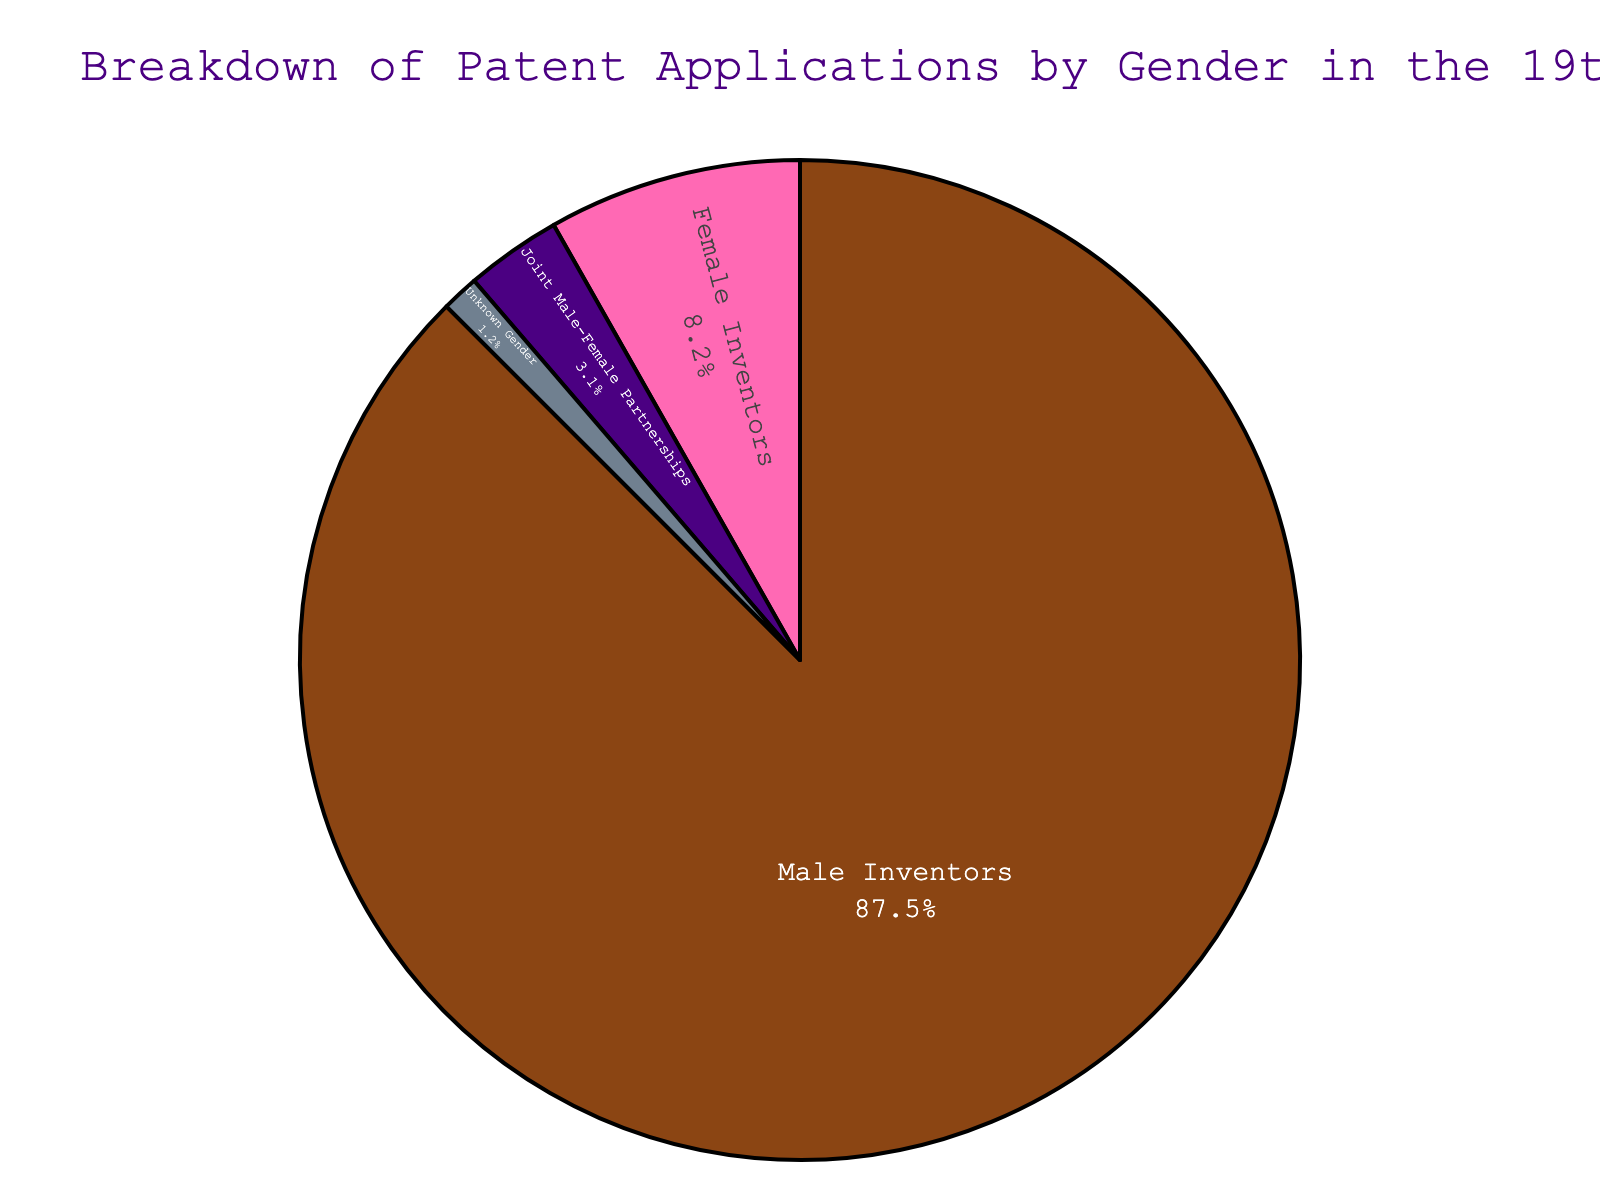What percentage of patent applications were made by joint male-female partnerships? To find the percentage of patent applications made by joint male-female partnerships, refer to the section of the pie chart labeled "Joint Male-Female Partnerships".
Answer: 3.1% Which category has the highest percentage of patent applications? Examine the different sections of the pie chart and identify the one with the largest area, which visually represents the highest percentage.
Answer: Male Inventors What is the total percentage of patent applications made by either female inventors or joint male-female partnerships? Add up the percentage for Female Inventors (8.2) and Joint Male-Female Partnerships (3.1). The total is 8.2 + 3.1 = 11.3%.
Answer: 11.3% How does the percentage of patent applications made by unknown gender compare to those made by female inventors? Compare the percentage of Unknown Gender (1.2%) to the percentage of Female Inventors (8.2%). Because 1.2% is less than 8.2%, there are fewer patent applications by unknown gender than female inventors.
Answer: Less than By how much does the percentage of male inventors exceed the percentage of female inventors? Subtract the percentage of Female Inventors (8.2%) from the percentage of Male Inventors (87.5%). The difference is 87.5 - 8.2 = 79.3%.
Answer: 79.3% Among the categories, which one has the smallest representation in the pie chart? Look at the pie chart sections and identify the one with the smallest area, representing the smallest percentage.
Answer: Unknown Gender What is the combined percentage of applications from male inventors, female inventors, and joint partnerships? Sum the percentages of Male Inventors (87.5%), Female Inventors (8.2%), and Joint Male-Female Partnerships (3.1%). The total is 87.5 + 8.2 + 3.1 = 98.8%.
Answer: 98.8% If the "Unknown Gender" category increased by 1%, what would the new percentage be? Add 1% to the current percentage of Unknown Gender (1.2%). The new percentage is 1.2 + 1 = 2.2%.
Answer: 2.2% 